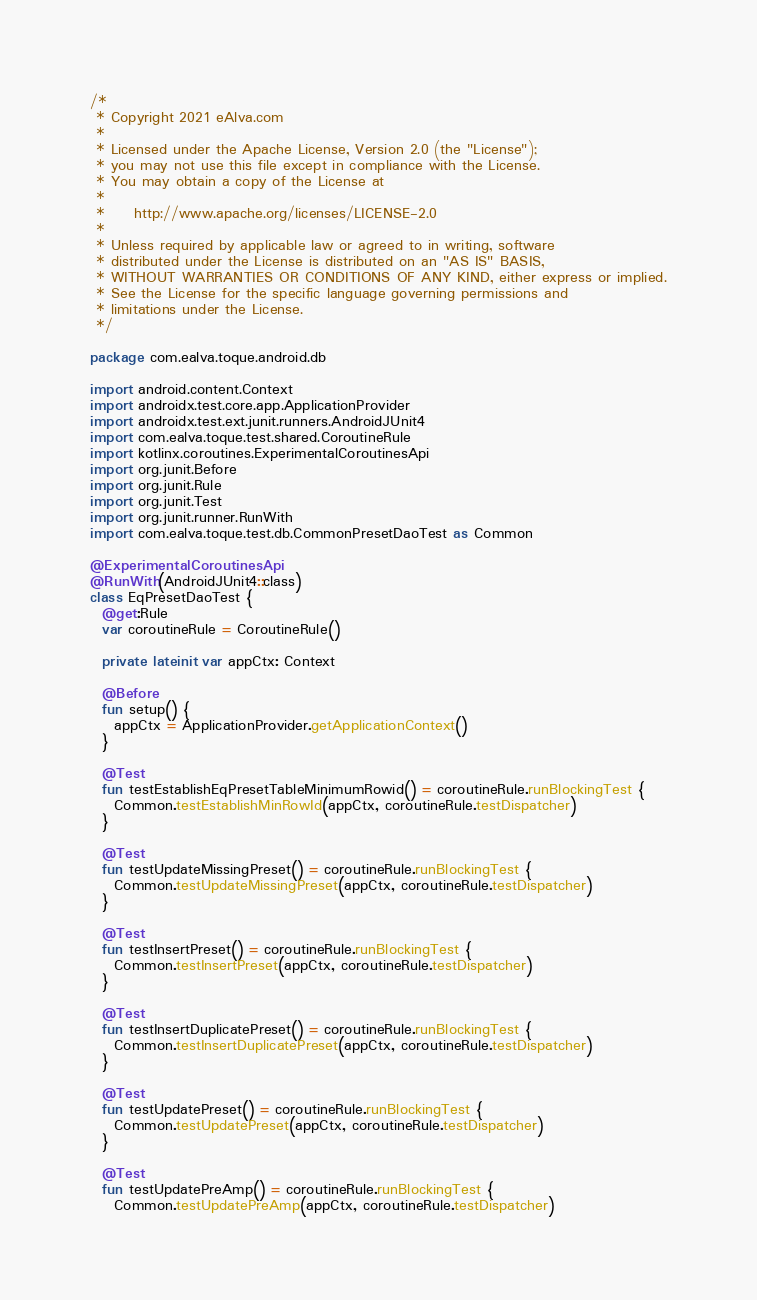<code> <loc_0><loc_0><loc_500><loc_500><_Kotlin_>/*
 * Copyright 2021 eAlva.com
 *
 * Licensed under the Apache License, Version 2.0 (the "License");
 * you may not use this file except in compliance with the License.
 * You may obtain a copy of the License at
 *
 *     http://www.apache.org/licenses/LICENSE-2.0
 *
 * Unless required by applicable law or agreed to in writing, software
 * distributed under the License is distributed on an "AS IS" BASIS,
 * WITHOUT WARRANTIES OR CONDITIONS OF ANY KIND, either express or implied.
 * See the License for the specific language governing permissions and
 * limitations under the License.
 */

package com.ealva.toque.android.db

import android.content.Context
import androidx.test.core.app.ApplicationProvider
import androidx.test.ext.junit.runners.AndroidJUnit4
import com.ealva.toque.test.shared.CoroutineRule
import kotlinx.coroutines.ExperimentalCoroutinesApi
import org.junit.Before
import org.junit.Rule
import org.junit.Test
import org.junit.runner.RunWith
import com.ealva.toque.test.db.CommonPresetDaoTest as Common

@ExperimentalCoroutinesApi
@RunWith(AndroidJUnit4::class)
class EqPresetDaoTest {
  @get:Rule
  var coroutineRule = CoroutineRule()

  private lateinit var appCtx: Context

  @Before
  fun setup() {
    appCtx = ApplicationProvider.getApplicationContext()
  }

  @Test
  fun testEstablishEqPresetTableMinimumRowid() = coroutineRule.runBlockingTest {
    Common.testEstablishMinRowId(appCtx, coroutineRule.testDispatcher)
  }

  @Test
  fun testUpdateMissingPreset() = coroutineRule.runBlockingTest {
    Common.testUpdateMissingPreset(appCtx, coroutineRule.testDispatcher)
  }

  @Test
  fun testInsertPreset() = coroutineRule.runBlockingTest {
    Common.testInsertPreset(appCtx, coroutineRule.testDispatcher)
  }

  @Test
  fun testInsertDuplicatePreset() = coroutineRule.runBlockingTest {
    Common.testInsertDuplicatePreset(appCtx, coroutineRule.testDispatcher)
  }

  @Test
  fun testUpdatePreset() = coroutineRule.runBlockingTest {
    Common.testUpdatePreset(appCtx, coroutineRule.testDispatcher)
  }

  @Test
  fun testUpdatePreAmp() = coroutineRule.runBlockingTest {
    Common.testUpdatePreAmp(appCtx, coroutineRule.testDispatcher)</code> 